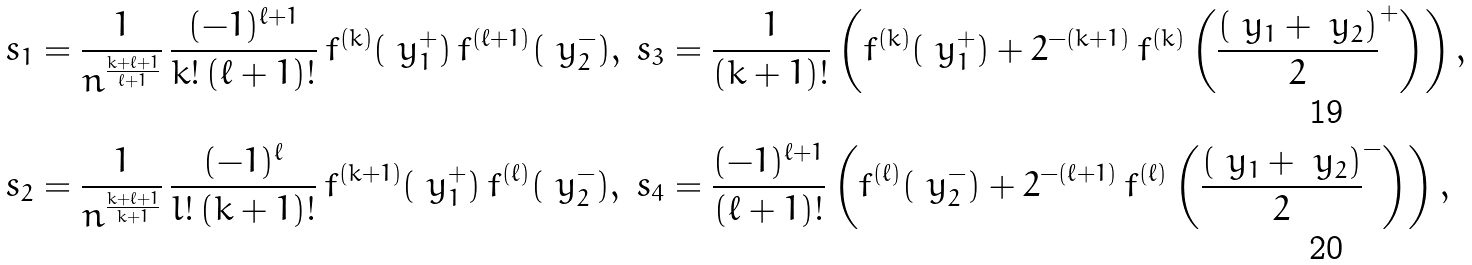Convert formula to latex. <formula><loc_0><loc_0><loc_500><loc_500>s _ { 1 } & = \frac { 1 } { n ^ { \frac { k + \ell + 1 } { \ell + 1 } } } \, \frac { ( - 1 ) ^ { \ell + 1 } } { k ! \, ( \ell + 1 ) ! } \, f ^ { ( k ) } ( \ y _ { 1 } ^ { + } ) \, f ^ { ( \ell + 1 ) } ( \ y _ { 2 } ^ { - } ) , & s _ { 3 } & = \frac { 1 } { ( k + 1 ) ! } \left ( f ^ { ( k ) } ( \ y _ { 1 } ^ { + } ) + 2 ^ { - ( k + 1 ) } \, f ^ { ( k ) } \left ( \frac { ( \ y _ { 1 } + \ y _ { 2 } ) } { 2 } ^ { + } \right ) \right ) , \\ s _ { 2 } & = \frac { 1 } { n ^ { \frac { k + \ell + 1 } { k + 1 } } } \, \frac { ( - 1 ) ^ { \ell } } { l ! \, ( k + 1 ) ! } \, f ^ { ( k + 1 ) } ( \ y _ { 1 } ^ { + } ) \, f ^ { ( \ell ) } ( \ y _ { 2 } ^ { - } ) , & s _ { 4 } & = \frac { ( - 1 ) ^ { \ell + 1 } } { ( \ell + 1 ) ! } \left ( f ^ { ( \ell ) } ( \ y _ { 2 } ^ { - } ) + 2 ^ { - ( \ell + 1 ) } \, f ^ { ( \ell ) } \left ( \frac { ( \ y _ { 1 } + \ y _ { 2 } ) } { 2 } ^ { - } \right ) \right ) ,</formula> 